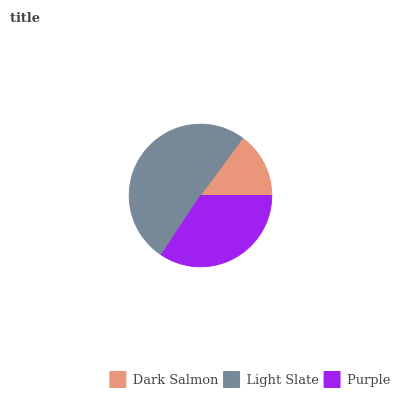Is Dark Salmon the minimum?
Answer yes or no. Yes. Is Light Slate the maximum?
Answer yes or no. Yes. Is Purple the minimum?
Answer yes or no. No. Is Purple the maximum?
Answer yes or no. No. Is Light Slate greater than Purple?
Answer yes or no. Yes. Is Purple less than Light Slate?
Answer yes or no. Yes. Is Purple greater than Light Slate?
Answer yes or no. No. Is Light Slate less than Purple?
Answer yes or no. No. Is Purple the high median?
Answer yes or no. Yes. Is Purple the low median?
Answer yes or no. Yes. Is Dark Salmon the high median?
Answer yes or no. No. Is Light Slate the low median?
Answer yes or no. No. 